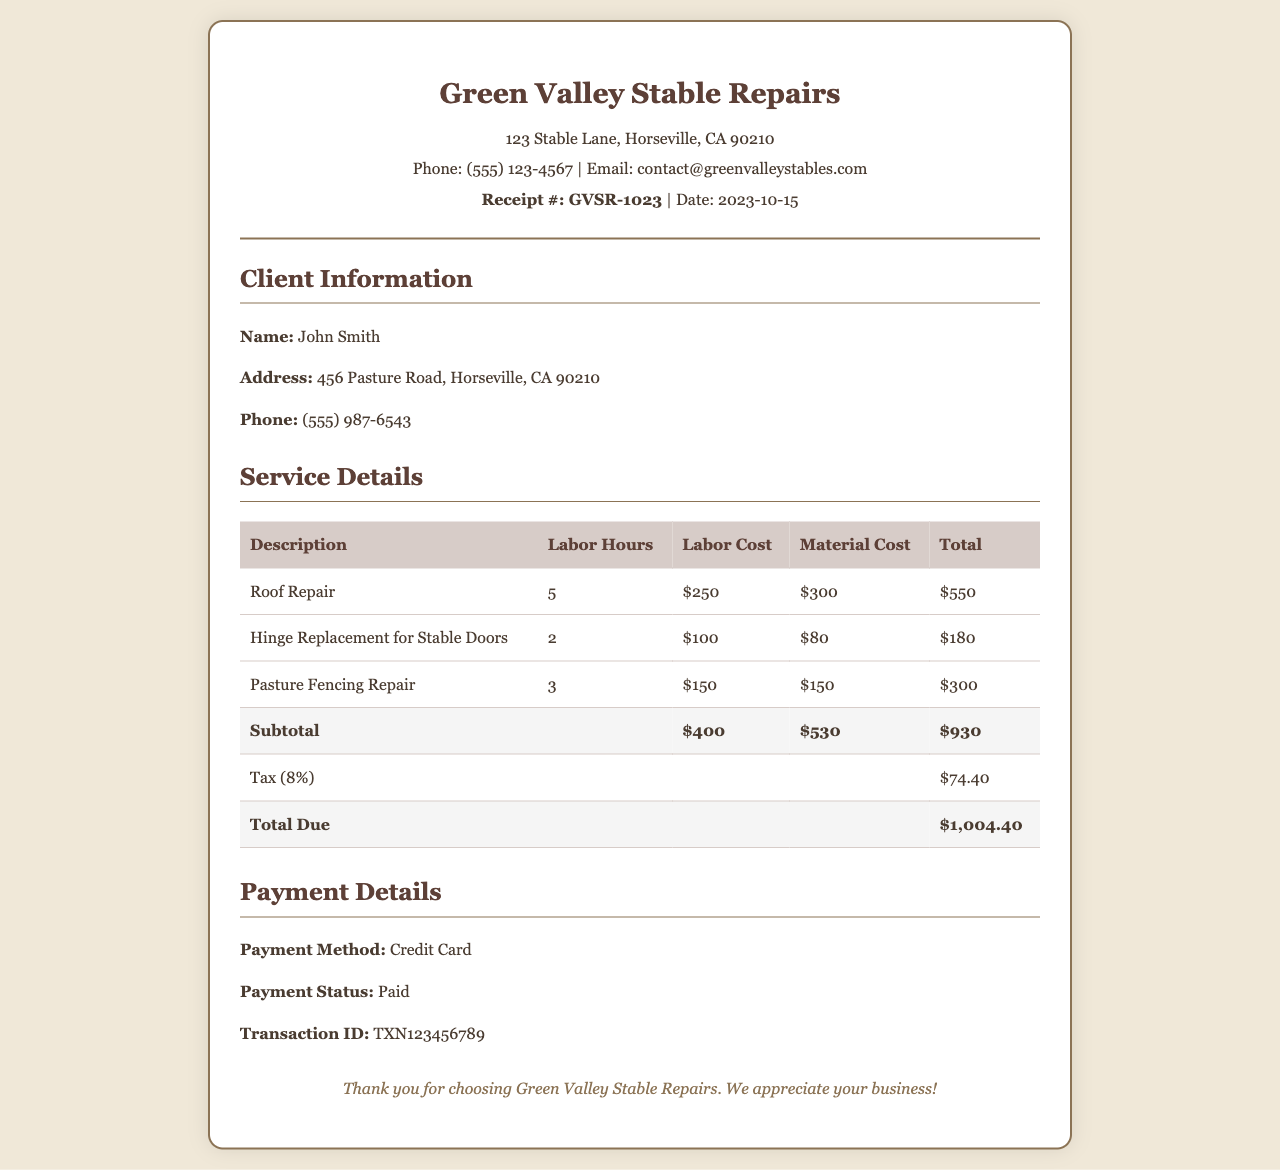What is the receipt number? The receipt number is explicitly mentioned in the document for identification, which is GVSR-1023.
Answer: GVSR-1023 What is the total amount due? The total amount due is calculated after adding all costs and tax, which is $1,004.40.
Answer: $1,004.40 How many hours were spent on roof repair? The document indicates that the labor hours devoted to roof repair were 5.
Answer: 5 What is the tax percentage applied? The tax percentage is stated in the document, which is 8%.
Answer: 8% Who is the client for this receipt? The client's name is specified within the document, which is John Smith.
Answer: John Smith What was the labor cost for hinge replacement? The labor cost for hinge replacement is detailed in the service section, which is $100.
Answer: $100 What is the total cost of materials? The total cost of materials is the sum of all material costs listed, which is $530.
Answer: $530 What payment method was used? The payment method is clearly indicated in the document, which is Credit Card.
Answer: Credit Card How much was spent on pasture fencing repair? The total cost for pasture fencing repair is detailed, which is $300.
Answer: $300 